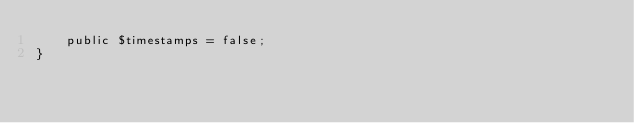<code> <loc_0><loc_0><loc_500><loc_500><_PHP_>    public $timestamps = false;
}
</code> 